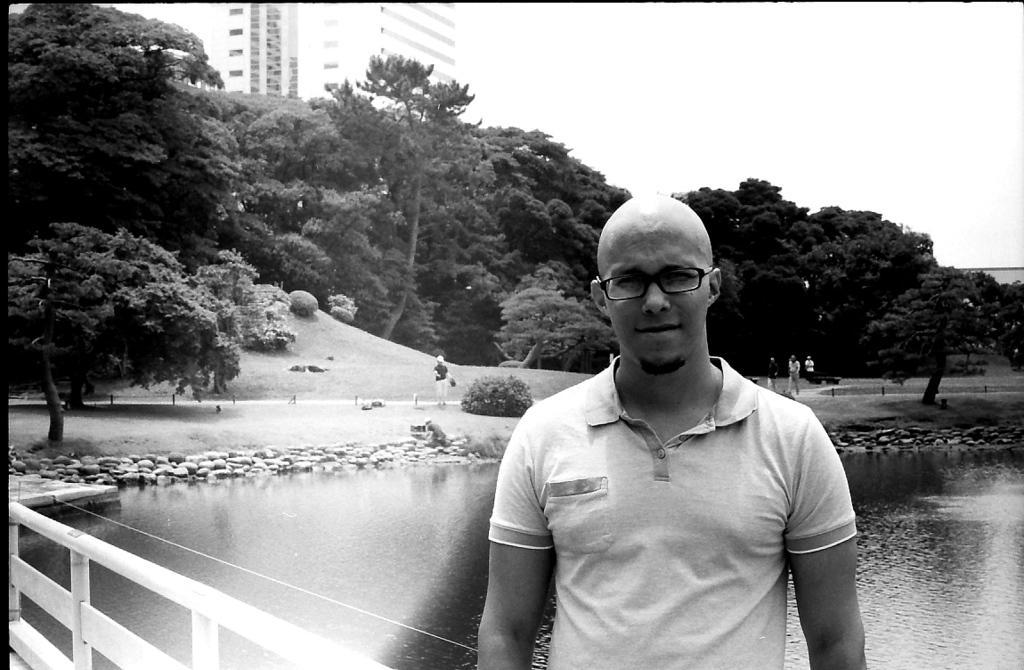Please provide a concise description of this image. In the image I can see a person standing in front of the fencing and behind there is a lake and around there are some trees, people and buildings. 